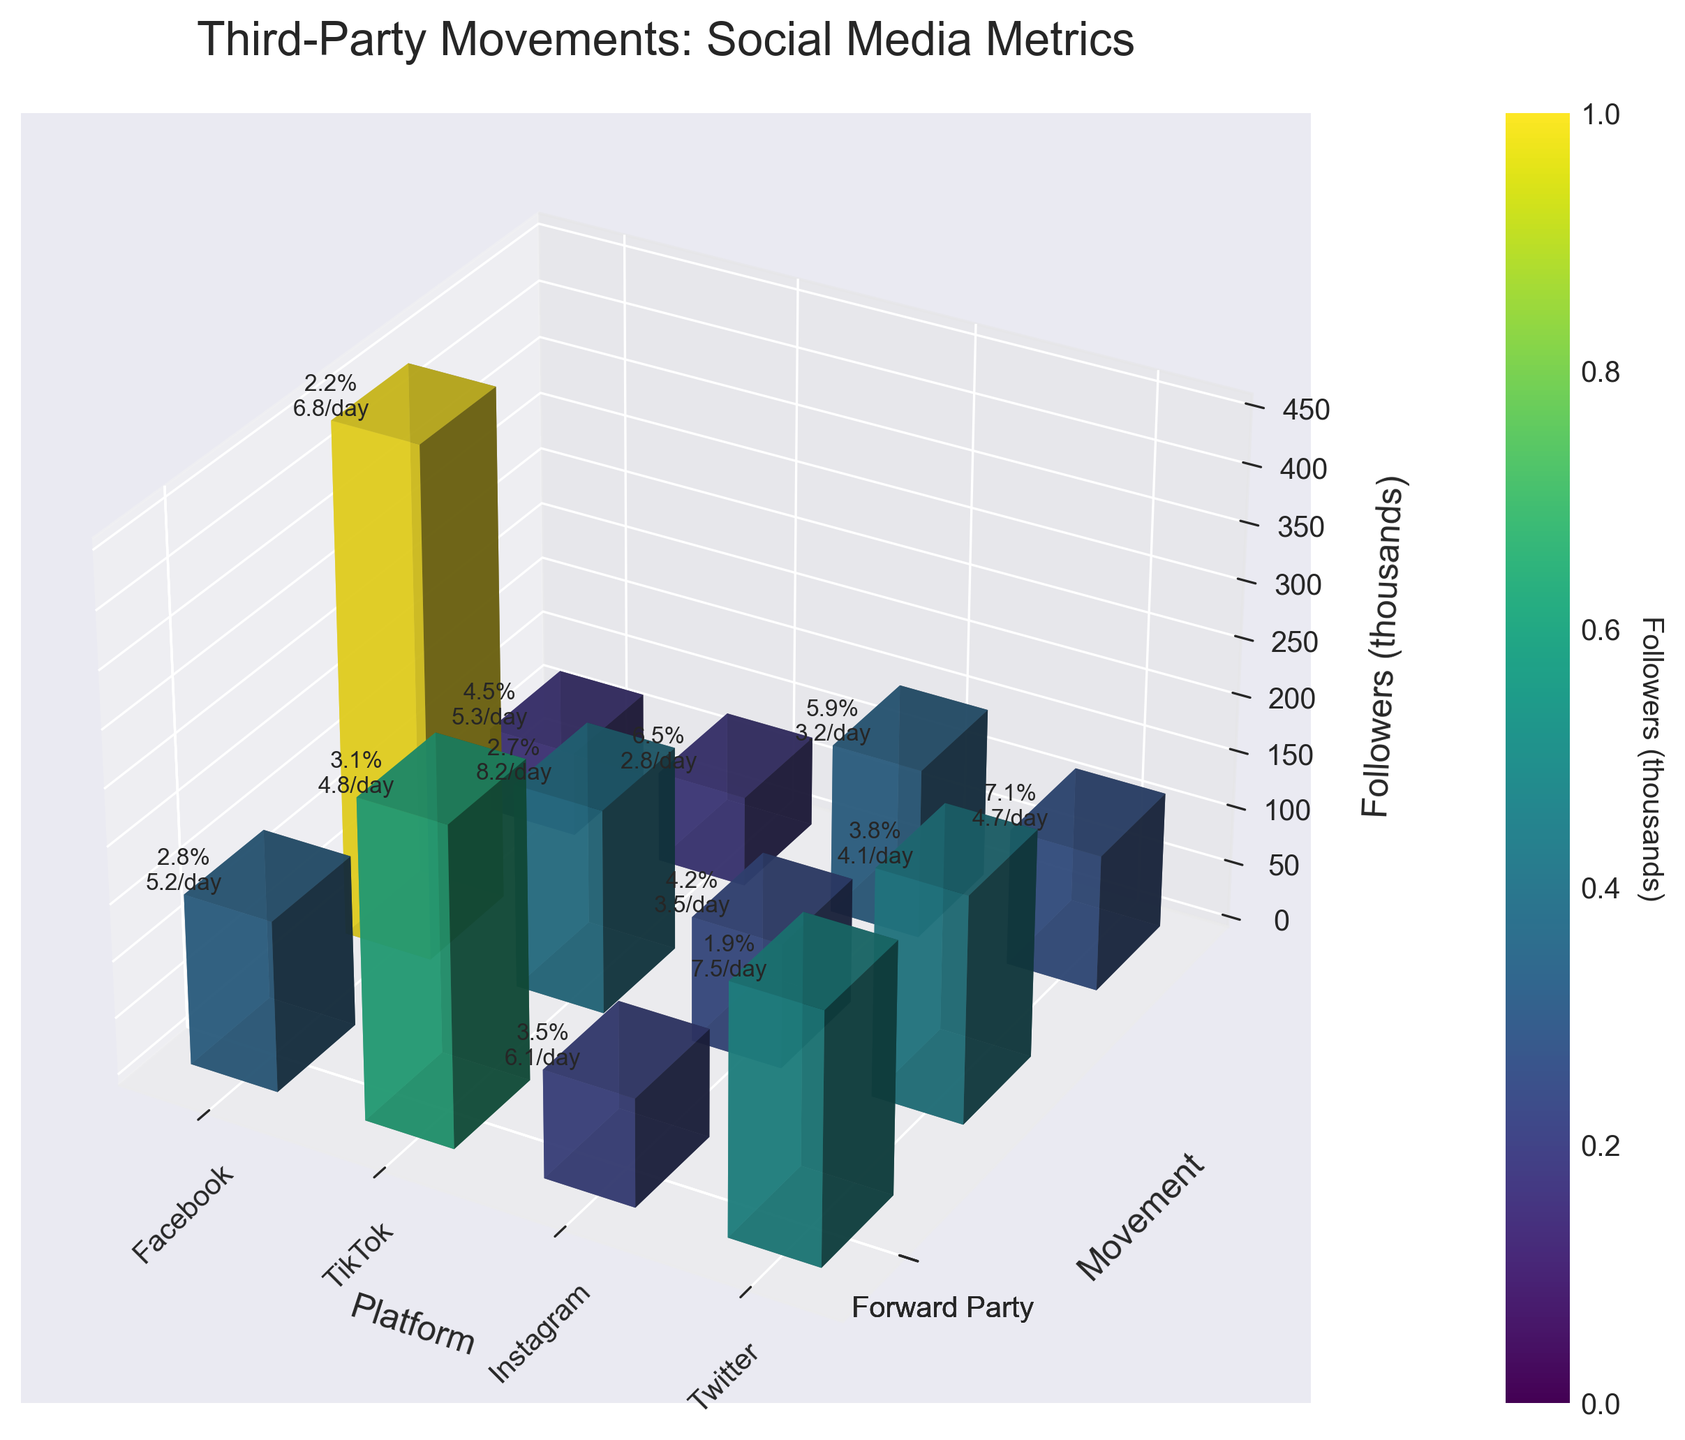What is the title of the 3D bar plot? The title of the plot is stated at the top above the 3D bar plot.
Answer: Third-Party Movements: Social Media Metrics Which movement has the highest number of followers on Twitter? Observing the Twitter section of the plot shows that Libertarian Party has the tallest bar.
Answer: Libertarian Party What are the engagement rate and post frequency for the Green Party on TikTok? These values are written as text near the top of each bar. For the Green Party on TikTok, the text near the bar indicates 6.5% engagement rate and 2.8 posts per day.
Answer: 6.5%, 2.8/day How many platforms have the Forward Party with an engagement rate higher than 4%? Look at the bars marked with the Forward Party label and read the engagement rates, then count the occurrences where the engagement rate is above 4%.
Answer: 2 Which platform has the highest average engagement rate for all movements? For each platform, calculate the average engagement rate by summing the engagement rates of all movements and dividing by the number of movements. Then compare the averages. TikTok has the highest average engagement rate (6.5+5.9+7.1)/3 = 6.5.
Answer: TikTok On which platform does the Green Party have the lowest number of followers? Compare the heights of the Green Party bars across all platforms. The shortest bar corresponds to TikTok.
Answer: TikTok Which movement posts most frequently on Instagram? Refer to the bars labeled as Instagram and check the text for post frequency. Forward Party posts the most frequently, indicated by 5.3 posts per day.
Answer: Forward Party How does the number of followers for the Forward Party compare between Facebook and Instagram? Compare the heights of the Forward Party bars on Facebook and Instagram. The Forward Party has fewer followers on Instagram (75,000) compared to Facebook (95,000).
Answer: Facebook > Instagram What's the color associated with bars representing the highest number of followers? The color of the bars corresponds to the number of followers, which can be inferred through color shading. The tallest bars are colored the darkest due to a higher number of followers.
Answer: Dark color Does post frequency correlate with the number of followers for the Forward Party? By observing the bars for the Forward Party across platforms, compare the heights representing followers with the text labels showing post frequency. Higher follower counts (especially on Facebook and Twitter) seem associated with higher post frequencies.
Answer: Yes 